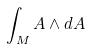<formula> <loc_0><loc_0><loc_500><loc_500>\int _ { M } A \wedge d A</formula> 